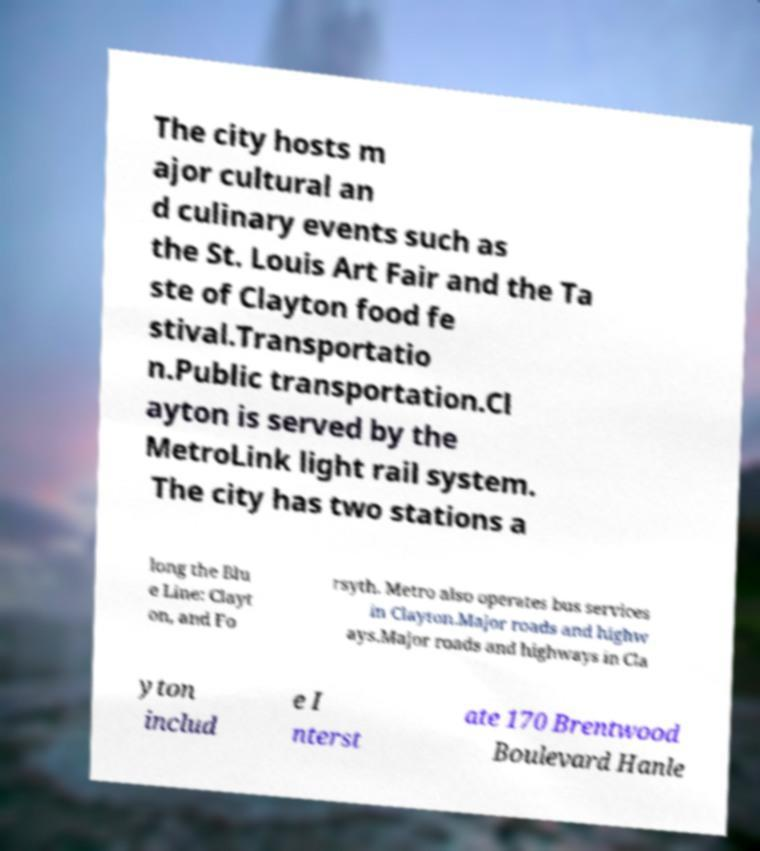There's text embedded in this image that I need extracted. Can you transcribe it verbatim? The city hosts m ajor cultural an d culinary events such as the St. Louis Art Fair and the Ta ste of Clayton food fe stival.Transportatio n.Public transportation.Cl ayton is served by the MetroLink light rail system. The city has two stations a long the Blu e Line: Clayt on, and Fo rsyth. Metro also operates bus services in Clayton.Major roads and highw ays.Major roads and highways in Cla yton includ e I nterst ate 170 Brentwood Boulevard Hanle 